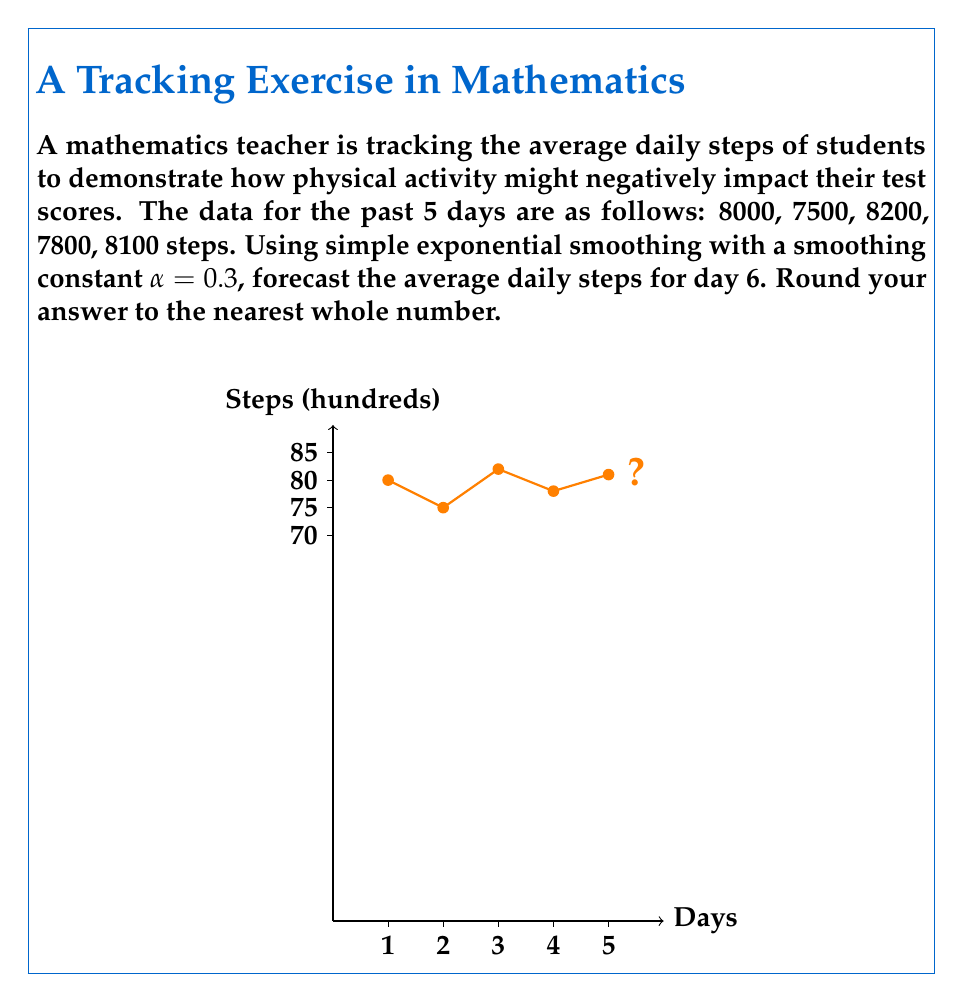Can you solve this math problem? To forecast future values using simple exponential smoothing, we use the formula:

$$F_{t+1} = \alpha Y_t + (1-\alpha)F_t$$

Where:
$F_{t+1}$ is the forecast for the next period
$\alpha$ is the smoothing constant (0.3 in this case)
$Y_t$ is the actual value for the current period
$F_t$ is the forecast for the current period

We start by initializing $F_1$ as the first observed value: 8000

Step 1: Calculate $F_2$
$$F_2 = 0.3(8000) + 0.7(8000) = 8000$$

Step 2: Calculate $F_3$
$$F_3 = 0.3(7500) + 0.7(8000) = 7850$$

Step 3: Calculate $F_4$
$$F_4 = 0.3(8200) + 0.7(7850) = 7955$$

Step 4: Calculate $F_5$
$$F_5 = 0.3(7800) + 0.7(7955) = 7908.5$$

Step 5: Calculate $F_6$ (our forecast)
$$F_6 = 0.3(8100) + 0.7(7908.5) = 7965.95$$

Rounding to the nearest whole number: 7966
Answer: 7966 steps 